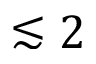<formula> <loc_0><loc_0><loc_500><loc_500>\lesssim 2</formula> 